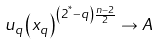Convert formula to latex. <formula><loc_0><loc_0><loc_500><loc_500>u _ { q } \left ( x _ { q } \right ) ^ { \left ( 2 ^ { ^ { * } } - q \right ) \frac { n - 2 } { 2 } } \to A</formula> 